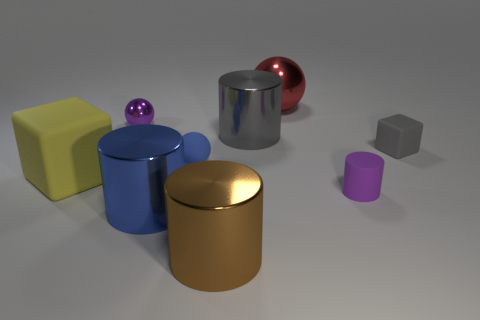What is the material of the yellow object?
Your answer should be very brief. Rubber. There is a block that is right of the blue shiny thing; what material is it?
Keep it short and to the point. Rubber. Are there any other things that have the same color as the big rubber block?
Make the answer very short. No. What size is the purple sphere that is the same material as the large brown cylinder?
Provide a short and direct response. Small. How many tiny things are either gray cylinders or purple spheres?
Give a very brief answer. 1. There is a cylinder behind the tiny gray rubber block behind the purple object on the right side of the blue rubber object; what is its size?
Offer a very short reply. Large. What number of blue things are the same size as the brown metallic cylinder?
Give a very brief answer. 1. What number of objects are purple matte things or cylinders in front of the tiny cylinder?
Offer a terse response. 3. There is a tiny purple shiny object; what shape is it?
Provide a short and direct response. Sphere. Is the color of the tiny shiny object the same as the tiny rubber cylinder?
Make the answer very short. Yes. 